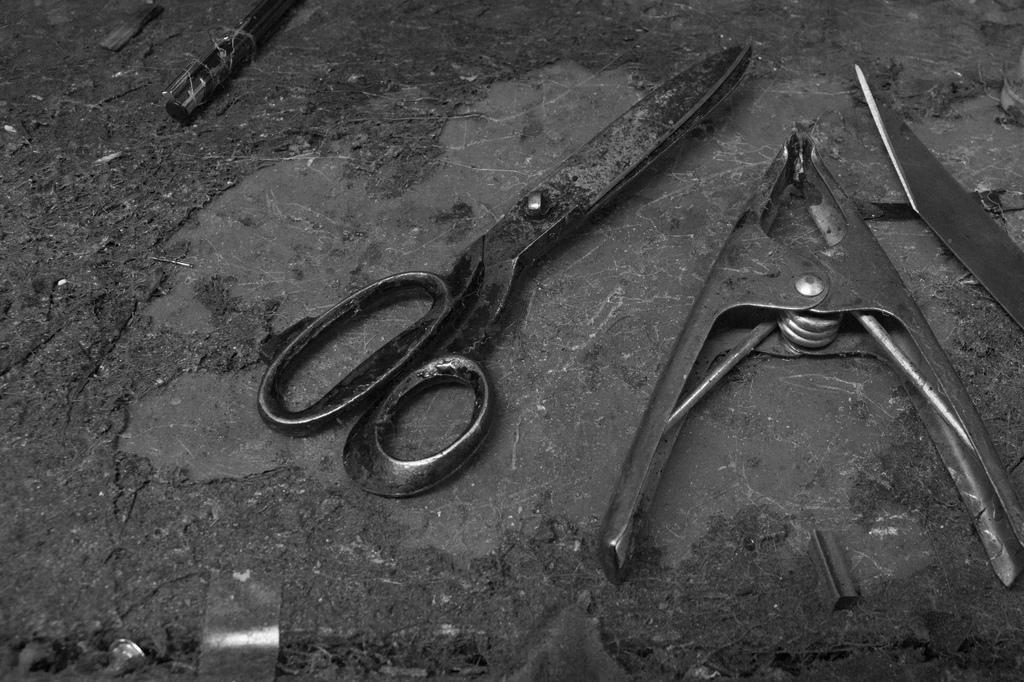How would you summarize this image in a sentence or two? In this picture we can see holder, knife, pen and other objects. At the bottom we can see the nails, steel chips and other materials. 